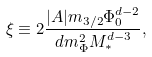<formula> <loc_0><loc_0><loc_500><loc_500>\xi \equiv 2 \frac { | A | m _ { 3 / 2 } \Phi _ { 0 } ^ { d - 2 } } { d m _ { \Phi } ^ { 2 } M _ { * } ^ { d - 3 } } ,</formula> 